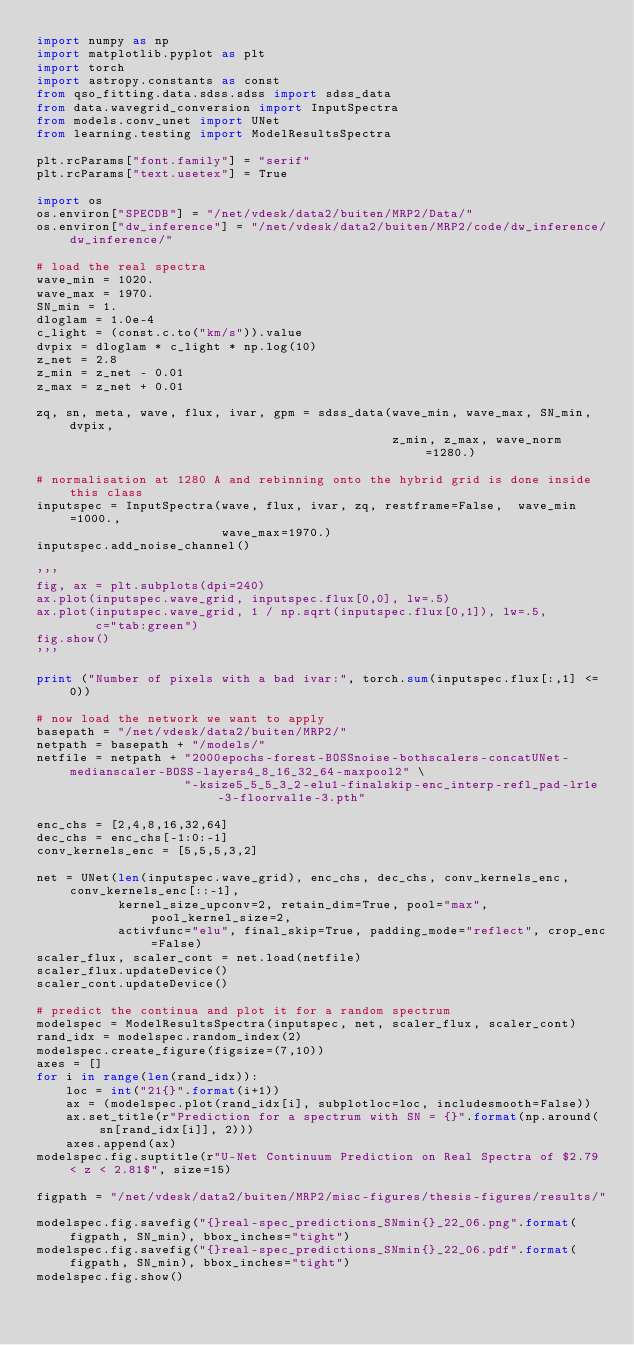Convert code to text. <code><loc_0><loc_0><loc_500><loc_500><_Python_>import numpy as np
import matplotlib.pyplot as plt
import torch
import astropy.constants as const
from qso_fitting.data.sdss.sdss import sdss_data
from data.wavegrid_conversion import InputSpectra
from models.conv_unet import UNet
from learning.testing import ModelResultsSpectra

plt.rcParams["font.family"] = "serif"
plt.rcParams["text.usetex"] = True

import os
os.environ["SPECDB"] = "/net/vdesk/data2/buiten/MRP2/Data/"
os.environ["dw_inference"] = "/net/vdesk/data2/buiten/MRP2/code/dw_inference/dw_inference/"

# load the real spectra
wave_min = 1020.
wave_max = 1970.
SN_min = 1.
dloglam = 1.0e-4
c_light = (const.c.to("km/s")).value
dvpix = dloglam * c_light * np.log(10)
z_net = 2.8
z_min = z_net - 0.01
z_max = z_net + 0.01

zq, sn, meta, wave, flux, ivar, gpm = sdss_data(wave_min, wave_max, SN_min, dvpix,
                                                z_min, z_max, wave_norm=1280.)

# normalisation at 1280 A and rebinning onto the hybrid grid is done inside this class
inputspec = InputSpectra(wave, flux, ivar, zq, restframe=False,  wave_min=1000.,
                         wave_max=1970.)
inputspec.add_noise_channel()

'''
fig, ax = plt.subplots(dpi=240)
ax.plot(inputspec.wave_grid, inputspec.flux[0,0], lw=.5)
ax.plot(inputspec.wave_grid, 1 / np.sqrt(inputspec.flux[0,1]), lw=.5,
        c="tab:green")
fig.show()
'''

print ("Number of pixels with a bad ivar:", torch.sum(inputspec.flux[:,1] <= 0))

# now load the network we want to apply
basepath = "/net/vdesk/data2/buiten/MRP2/"
netpath = basepath + "/models/"
netfile = netpath + "2000epochs-forest-BOSSnoise-bothscalers-concatUNet-medianscaler-BOSS-layers4_8_16_32_64-maxpool2" \
                    "-ksize5_5_5_3_2-elu1-finalskip-enc_interp-refl_pad-lr1e-3-floorval1e-3.pth"

enc_chs = [2,4,8,16,32,64]
dec_chs = enc_chs[-1:0:-1]
conv_kernels_enc = [5,5,5,3,2]

net = UNet(len(inputspec.wave_grid), enc_chs, dec_chs, conv_kernels_enc, conv_kernels_enc[::-1],
           kernel_size_upconv=2, retain_dim=True, pool="max", pool_kernel_size=2,
           activfunc="elu", final_skip=True, padding_mode="reflect", crop_enc=False)
scaler_flux, scaler_cont = net.load(netfile)
scaler_flux.updateDevice()
scaler_cont.updateDevice()

# predict the continua and plot it for a random spectrum
modelspec = ModelResultsSpectra(inputspec, net, scaler_flux, scaler_cont)
rand_idx = modelspec.random_index(2)
modelspec.create_figure(figsize=(7,10))
axes = []
for i in range(len(rand_idx)):
    loc = int("21{}".format(i+1))
    ax = (modelspec.plot(rand_idx[i], subplotloc=loc, includesmooth=False))
    ax.set_title(r"Prediction for a spectrum with SN = {}".format(np.around(sn[rand_idx[i]], 2)))
    axes.append(ax)
modelspec.fig.suptitle(r"U-Net Continuum Prediction on Real Spectra of $2.79 < z < 2.81$", size=15)

figpath = "/net/vdesk/data2/buiten/MRP2/misc-figures/thesis-figures/results/"

modelspec.fig.savefig("{}real-spec_predictions_SNmin{}_22_06.png".format(figpath, SN_min), bbox_inches="tight")
modelspec.fig.savefig("{}real-spec_predictions_SNmin{}_22_06.pdf".format(figpath, SN_min), bbox_inches="tight")
modelspec.fig.show()</code> 